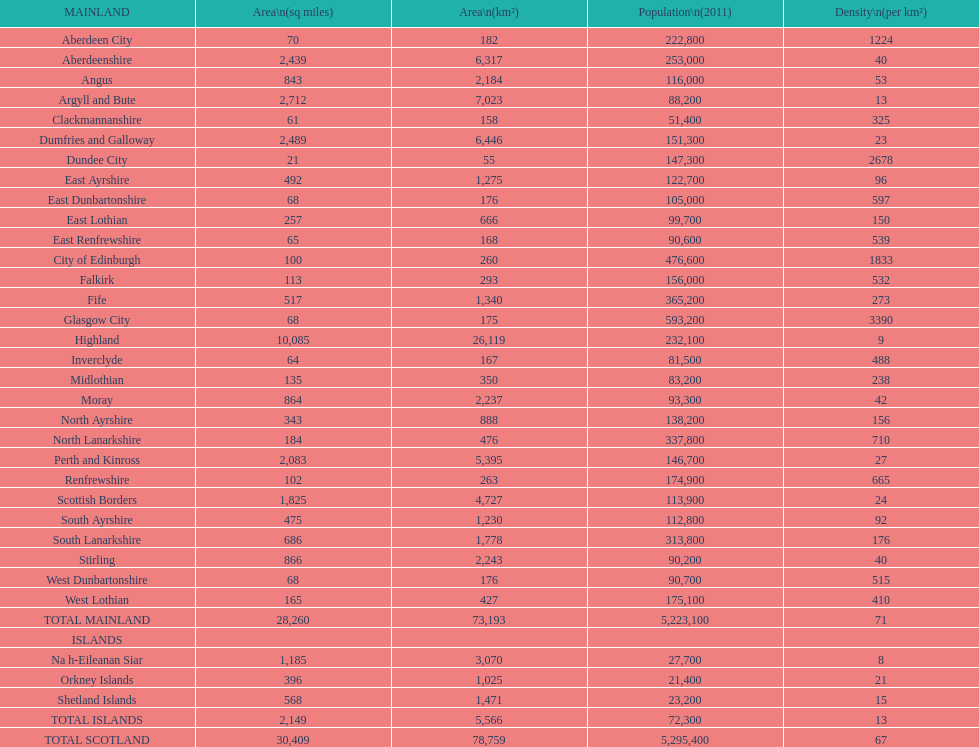What is the population of angus in 2011? 116,000. 